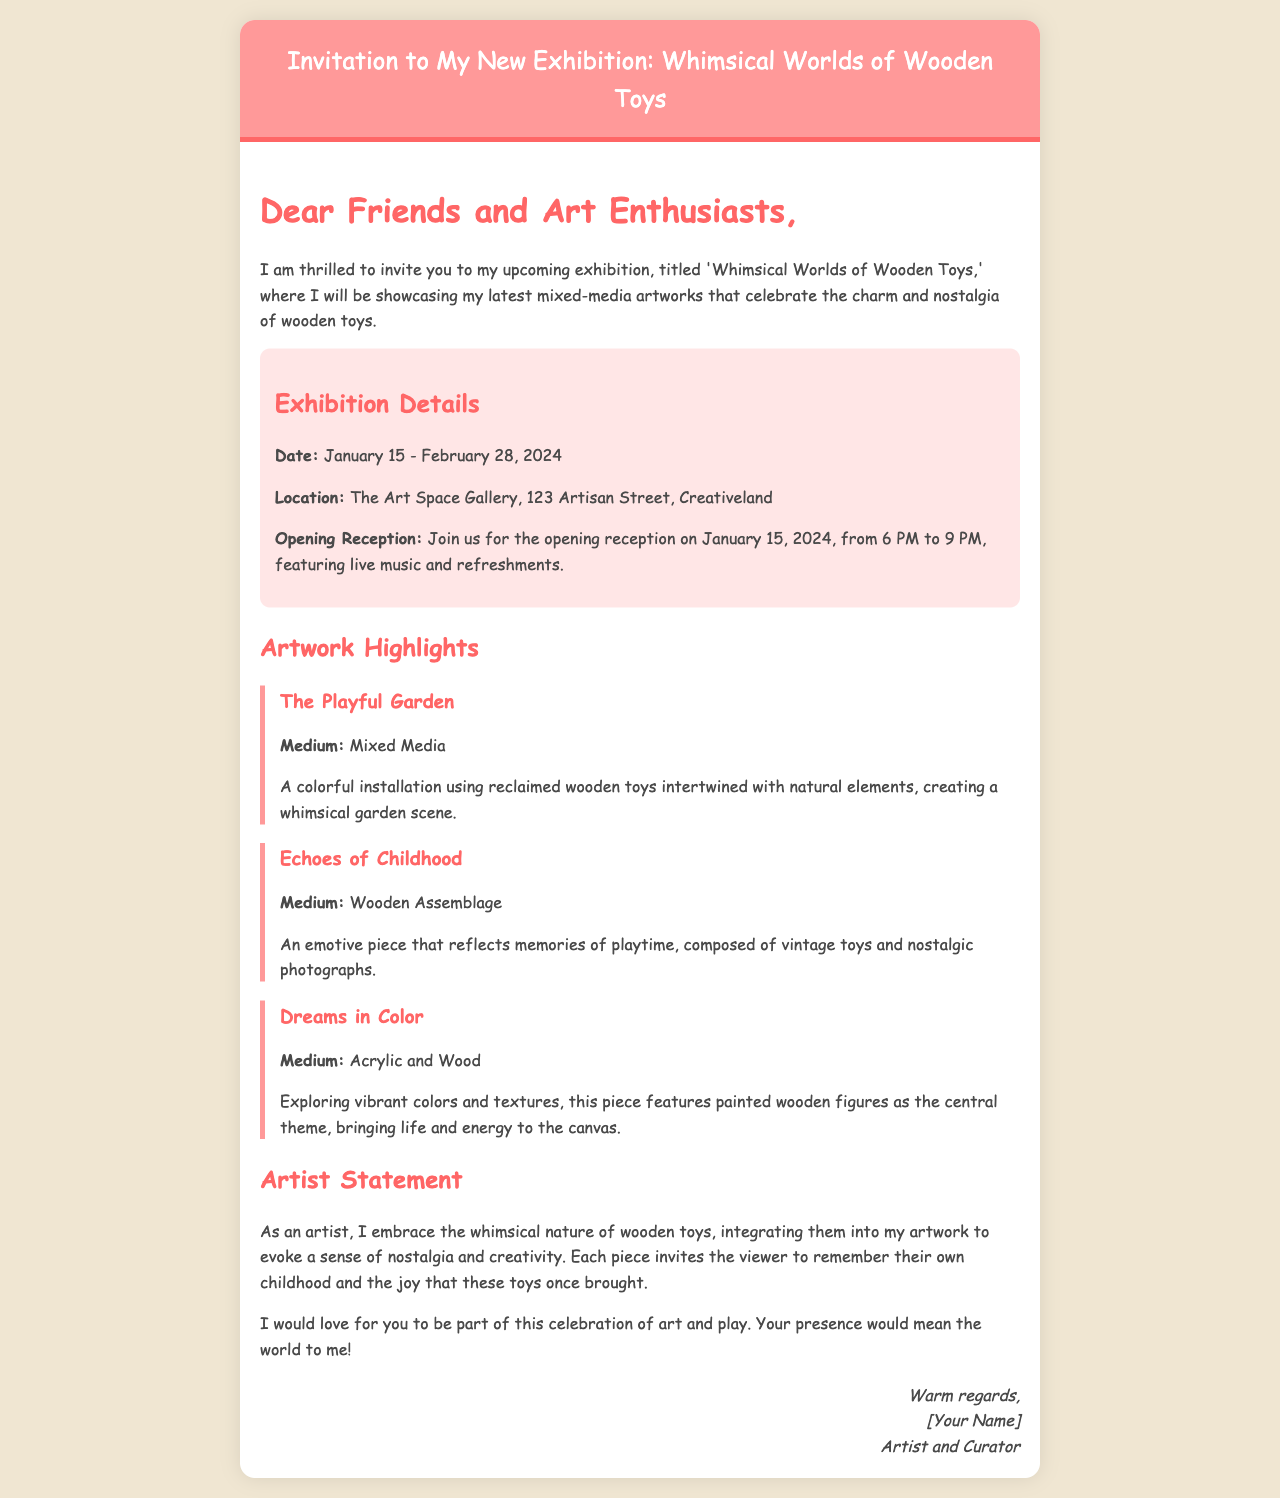What is the title of the exhibition? The title of the exhibition is explicitly mentioned in the document as 'Whimsical Worlds of Wooden Toys'.
Answer: Whimsical Worlds of Wooden Toys When does the exhibition open? The opening date of the exhibition is stated in the document, which is January 15, 2024.
Answer: January 15, 2024 Where is the exhibition located? The location of the exhibition is provided in the document as The Art Space Gallery, 123 Artisan Street, Creativeland.
Answer: The Art Space Gallery, 123 Artisan Street, Creativeland What is one of the artwork highlights? The document lists multiple artwork highlights, one of which is 'The Playful Garden'.
Answer: The Playful Garden What kind of reception will be held at the opening? The document mentions that the opening reception will feature live music and refreshments.
Answer: Live music and refreshments What is the medium of the artwork 'Echoes of Childhood'? The document specifies the medium used for 'Echoes of Childhood' as Wooden Assemblage.
Answer: Wooden Assemblage How long is the exhibition running? The exhibition runs from January 15 to February 28, 2024, which is a total of 44 days.
Answer: 44 days What is the artist’s intention with the artworks? The artist expresses the intention to evoke nostalgia and creativity through the use of wooden toys in the artwork.
Answer: Evoke nostalgia and creativity What is the date of the opening reception? The document provides the date of the opening reception as January 15, 2024.
Answer: January 15, 2024 